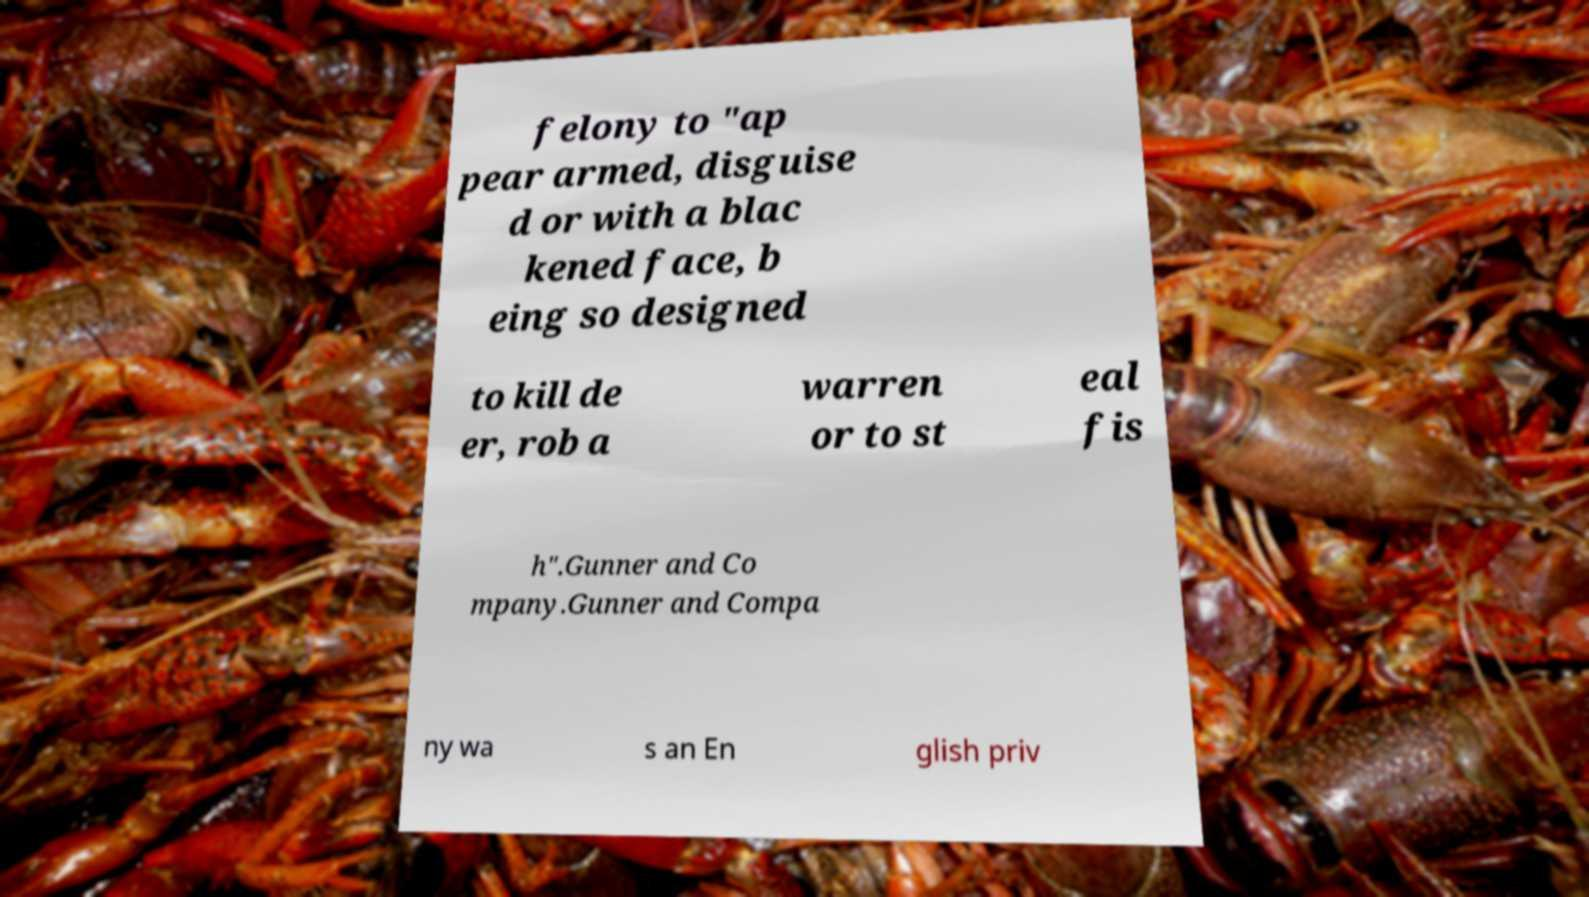Please identify and transcribe the text found in this image. felony to "ap pear armed, disguise d or with a blac kened face, b eing so designed to kill de er, rob a warren or to st eal fis h".Gunner and Co mpany.Gunner and Compa ny wa s an En glish priv 